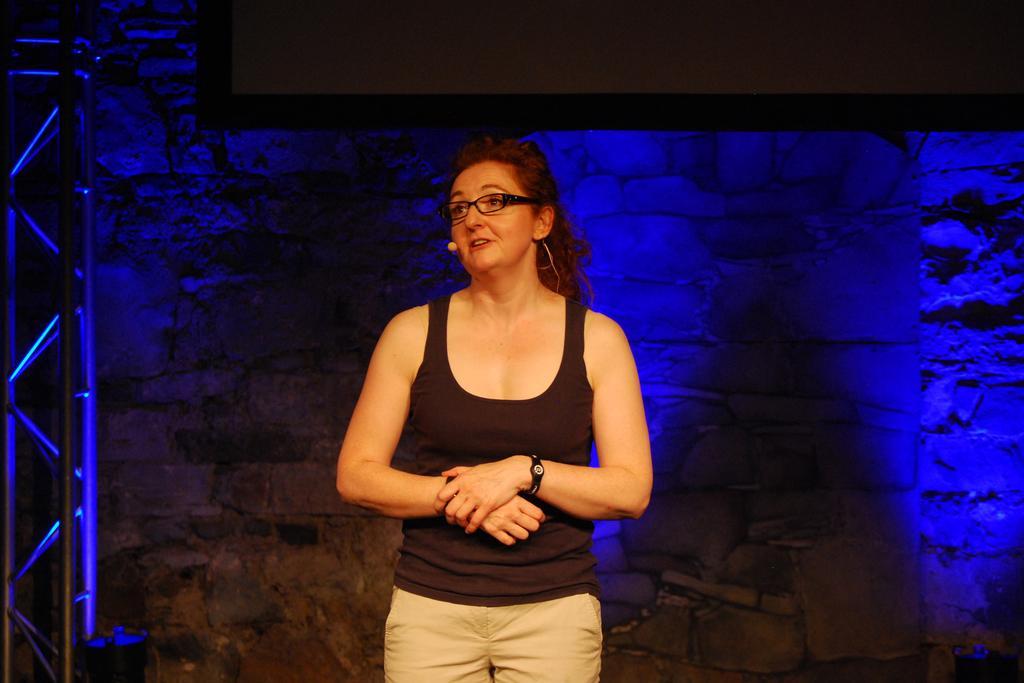In one or two sentences, can you explain what this image depicts? In the center of the image there is a woman standing on the floor. In the background there is a wall and screen. 